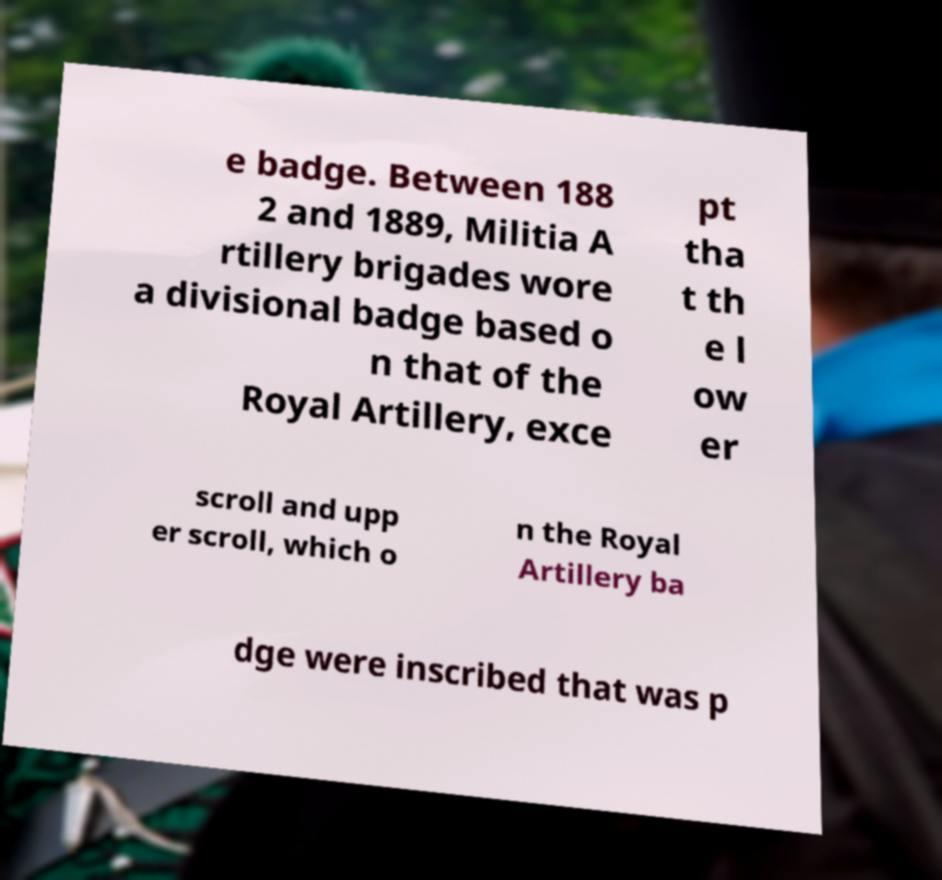For documentation purposes, I need the text within this image transcribed. Could you provide that? e badge. Between 188 2 and 1889, Militia A rtillery brigades wore a divisional badge based o n that of the Royal Artillery, exce pt tha t th e l ow er scroll and upp er scroll, which o n the Royal Artillery ba dge were inscribed that was p 